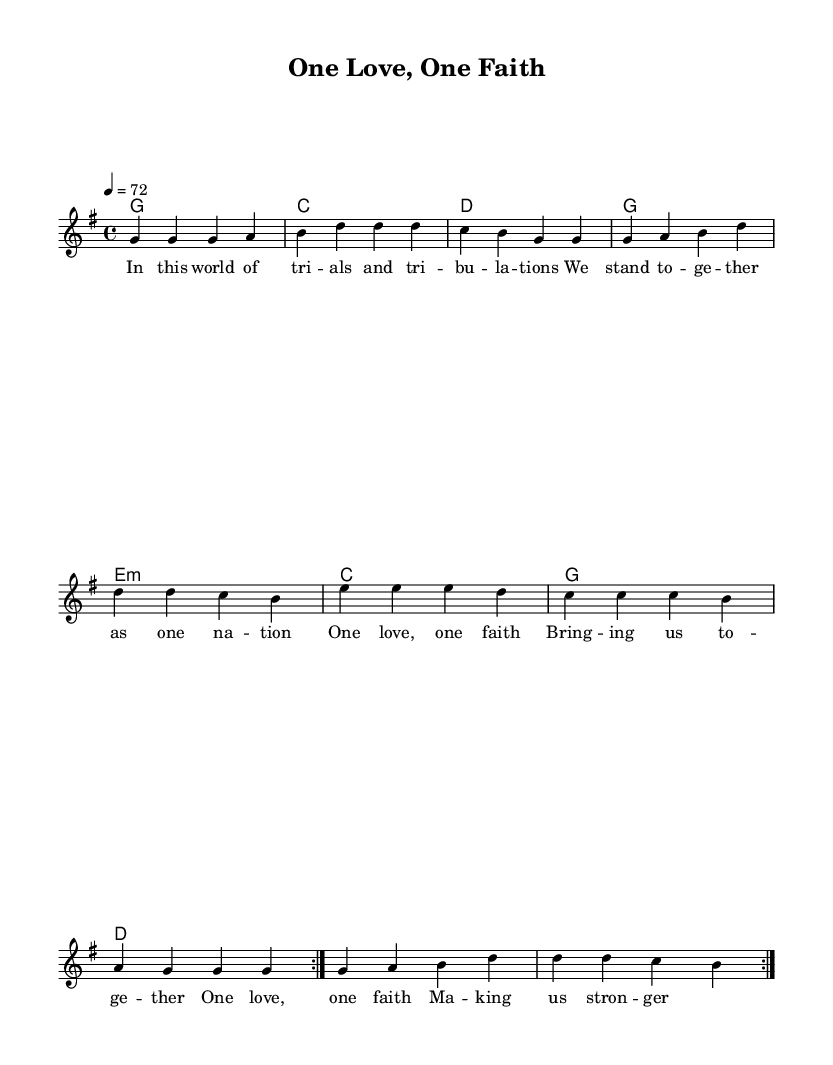What is the key signature of this music? The key signature is G major, indicated by one sharp (F#).
Answer: G major What is the time signature of this music? The time signature is 4/4, meaning there are four beats per measure.
Answer: 4/4 What is the tempo marking for this piece? The tempo marking indicates a speed of 72 beats per minute.
Answer: 72 How many measures are repeated in the melody? The melody has a repeat indication for two measures, shown by the volta sign.
Answer: 2 What is the primary theme of the lyrics? The lyrics focus on unity and strength through faith and love.
Answer: Unity and strength Which chord is played on the first measure? The first measure shows a G major chord, noted as a G1 in the harmonies section.
Answer: G major How does this piece reflect the reggae music style? The piece features a laid-back rhythm and emphasizes themes of community and togetherness, common in reggae.
Answer: Community and togetherness 